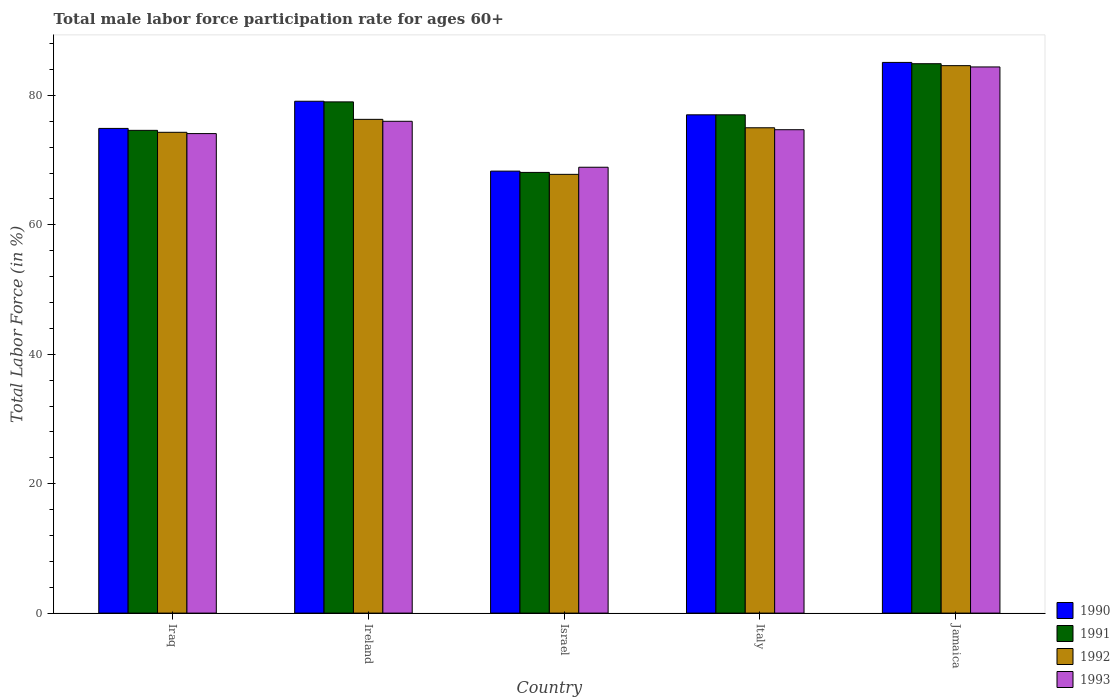How many different coloured bars are there?
Ensure brevity in your answer.  4. How many bars are there on the 1st tick from the right?
Your answer should be very brief. 4. What is the label of the 5th group of bars from the left?
Provide a short and direct response. Jamaica. In how many cases, is the number of bars for a given country not equal to the number of legend labels?
Give a very brief answer. 0. What is the male labor force participation rate in 1990 in Ireland?
Your response must be concise. 79.1. Across all countries, what is the maximum male labor force participation rate in 1992?
Your answer should be compact. 84.6. Across all countries, what is the minimum male labor force participation rate in 1990?
Your answer should be very brief. 68.3. In which country was the male labor force participation rate in 1990 maximum?
Offer a terse response. Jamaica. In which country was the male labor force participation rate in 1990 minimum?
Your answer should be compact. Israel. What is the total male labor force participation rate in 1991 in the graph?
Keep it short and to the point. 383.6. What is the difference between the male labor force participation rate in 1992 in Israel and that in Jamaica?
Provide a short and direct response. -16.8. What is the difference between the male labor force participation rate in 1990 in Israel and the male labor force participation rate in 1991 in Jamaica?
Offer a very short reply. -16.6. What is the average male labor force participation rate in 1991 per country?
Give a very brief answer. 76.72. What is the difference between the male labor force participation rate of/in 1992 and male labor force participation rate of/in 1990 in Jamaica?
Your answer should be compact. -0.5. What is the ratio of the male labor force participation rate in 1992 in Italy to that in Jamaica?
Make the answer very short. 0.89. Is the difference between the male labor force participation rate in 1992 in Israel and Jamaica greater than the difference between the male labor force participation rate in 1990 in Israel and Jamaica?
Provide a short and direct response. No. What is the difference between the highest and the second highest male labor force participation rate in 1990?
Make the answer very short. -8.1. What is the difference between the highest and the lowest male labor force participation rate in 1990?
Your answer should be very brief. 16.8. Is the sum of the male labor force participation rate in 1991 in Israel and Italy greater than the maximum male labor force participation rate in 1990 across all countries?
Keep it short and to the point. Yes. What does the 1st bar from the right in Jamaica represents?
Make the answer very short. 1993. Is it the case that in every country, the sum of the male labor force participation rate in 1993 and male labor force participation rate in 1992 is greater than the male labor force participation rate in 1990?
Your answer should be very brief. Yes. Are all the bars in the graph horizontal?
Offer a terse response. No. Does the graph contain grids?
Your response must be concise. No. Where does the legend appear in the graph?
Offer a terse response. Bottom right. What is the title of the graph?
Make the answer very short. Total male labor force participation rate for ages 60+. What is the label or title of the X-axis?
Your answer should be very brief. Country. What is the label or title of the Y-axis?
Give a very brief answer. Total Labor Force (in %). What is the Total Labor Force (in %) of 1990 in Iraq?
Provide a succinct answer. 74.9. What is the Total Labor Force (in %) of 1991 in Iraq?
Your answer should be very brief. 74.6. What is the Total Labor Force (in %) of 1992 in Iraq?
Keep it short and to the point. 74.3. What is the Total Labor Force (in %) of 1993 in Iraq?
Your answer should be compact. 74.1. What is the Total Labor Force (in %) of 1990 in Ireland?
Ensure brevity in your answer.  79.1. What is the Total Labor Force (in %) of 1991 in Ireland?
Provide a short and direct response. 79. What is the Total Labor Force (in %) in 1992 in Ireland?
Keep it short and to the point. 76.3. What is the Total Labor Force (in %) of 1993 in Ireland?
Provide a succinct answer. 76. What is the Total Labor Force (in %) in 1990 in Israel?
Keep it short and to the point. 68.3. What is the Total Labor Force (in %) in 1991 in Israel?
Ensure brevity in your answer.  68.1. What is the Total Labor Force (in %) of 1992 in Israel?
Ensure brevity in your answer.  67.8. What is the Total Labor Force (in %) of 1993 in Israel?
Keep it short and to the point. 68.9. What is the Total Labor Force (in %) in 1993 in Italy?
Offer a very short reply. 74.7. What is the Total Labor Force (in %) of 1990 in Jamaica?
Offer a very short reply. 85.1. What is the Total Labor Force (in %) of 1991 in Jamaica?
Give a very brief answer. 84.9. What is the Total Labor Force (in %) in 1992 in Jamaica?
Ensure brevity in your answer.  84.6. What is the Total Labor Force (in %) in 1993 in Jamaica?
Your answer should be compact. 84.4. Across all countries, what is the maximum Total Labor Force (in %) in 1990?
Your answer should be compact. 85.1. Across all countries, what is the maximum Total Labor Force (in %) of 1991?
Your answer should be very brief. 84.9. Across all countries, what is the maximum Total Labor Force (in %) of 1992?
Offer a very short reply. 84.6. Across all countries, what is the maximum Total Labor Force (in %) of 1993?
Ensure brevity in your answer.  84.4. Across all countries, what is the minimum Total Labor Force (in %) in 1990?
Ensure brevity in your answer.  68.3. Across all countries, what is the minimum Total Labor Force (in %) of 1991?
Your answer should be very brief. 68.1. Across all countries, what is the minimum Total Labor Force (in %) in 1992?
Provide a succinct answer. 67.8. Across all countries, what is the minimum Total Labor Force (in %) of 1993?
Offer a very short reply. 68.9. What is the total Total Labor Force (in %) of 1990 in the graph?
Make the answer very short. 384.4. What is the total Total Labor Force (in %) in 1991 in the graph?
Give a very brief answer. 383.6. What is the total Total Labor Force (in %) in 1992 in the graph?
Keep it short and to the point. 378. What is the total Total Labor Force (in %) in 1993 in the graph?
Give a very brief answer. 378.1. What is the difference between the Total Labor Force (in %) in 1990 in Iraq and that in Israel?
Your answer should be very brief. 6.6. What is the difference between the Total Labor Force (in %) of 1993 in Iraq and that in Israel?
Make the answer very short. 5.2. What is the difference between the Total Labor Force (in %) of 1993 in Iraq and that in Italy?
Offer a very short reply. -0.6. What is the difference between the Total Labor Force (in %) in 1990 in Iraq and that in Jamaica?
Offer a terse response. -10.2. What is the difference between the Total Labor Force (in %) of 1992 in Iraq and that in Jamaica?
Your answer should be very brief. -10.3. What is the difference between the Total Labor Force (in %) of 1993 in Iraq and that in Jamaica?
Provide a succinct answer. -10.3. What is the difference between the Total Labor Force (in %) of 1990 in Ireland and that in Israel?
Ensure brevity in your answer.  10.8. What is the difference between the Total Labor Force (in %) in 1991 in Ireland and that in Israel?
Provide a succinct answer. 10.9. What is the difference between the Total Labor Force (in %) in 1993 in Ireland and that in Israel?
Ensure brevity in your answer.  7.1. What is the difference between the Total Labor Force (in %) of 1991 in Ireland and that in Italy?
Offer a very short reply. 2. What is the difference between the Total Labor Force (in %) in 1990 in Ireland and that in Jamaica?
Offer a very short reply. -6. What is the difference between the Total Labor Force (in %) of 1991 in Ireland and that in Jamaica?
Your answer should be very brief. -5.9. What is the difference between the Total Labor Force (in %) in 1992 in Ireland and that in Jamaica?
Your response must be concise. -8.3. What is the difference between the Total Labor Force (in %) in 1993 in Ireland and that in Jamaica?
Offer a terse response. -8.4. What is the difference between the Total Labor Force (in %) of 1990 in Israel and that in Italy?
Keep it short and to the point. -8.7. What is the difference between the Total Labor Force (in %) in 1993 in Israel and that in Italy?
Make the answer very short. -5.8. What is the difference between the Total Labor Force (in %) of 1990 in Israel and that in Jamaica?
Your answer should be very brief. -16.8. What is the difference between the Total Labor Force (in %) in 1991 in Israel and that in Jamaica?
Give a very brief answer. -16.8. What is the difference between the Total Labor Force (in %) of 1992 in Israel and that in Jamaica?
Provide a succinct answer. -16.8. What is the difference between the Total Labor Force (in %) in 1993 in Israel and that in Jamaica?
Your response must be concise. -15.5. What is the difference between the Total Labor Force (in %) in 1991 in Italy and that in Jamaica?
Keep it short and to the point. -7.9. What is the difference between the Total Labor Force (in %) of 1990 in Iraq and the Total Labor Force (in %) of 1993 in Ireland?
Ensure brevity in your answer.  -1.1. What is the difference between the Total Labor Force (in %) in 1991 in Iraq and the Total Labor Force (in %) in 1993 in Ireland?
Keep it short and to the point. -1.4. What is the difference between the Total Labor Force (in %) of 1990 in Iraq and the Total Labor Force (in %) of 1993 in Israel?
Make the answer very short. 6. What is the difference between the Total Labor Force (in %) of 1991 in Iraq and the Total Labor Force (in %) of 1992 in Israel?
Provide a short and direct response. 6.8. What is the difference between the Total Labor Force (in %) in 1990 in Iraq and the Total Labor Force (in %) in 1993 in Italy?
Give a very brief answer. 0.2. What is the difference between the Total Labor Force (in %) of 1992 in Iraq and the Total Labor Force (in %) of 1993 in Italy?
Offer a terse response. -0.4. What is the difference between the Total Labor Force (in %) in 1990 in Iraq and the Total Labor Force (in %) in 1992 in Jamaica?
Provide a short and direct response. -9.7. What is the difference between the Total Labor Force (in %) in 1991 in Iraq and the Total Labor Force (in %) in 1992 in Jamaica?
Give a very brief answer. -10. What is the difference between the Total Labor Force (in %) in 1990 in Ireland and the Total Labor Force (in %) in 1991 in Israel?
Make the answer very short. 11. What is the difference between the Total Labor Force (in %) of 1990 in Ireland and the Total Labor Force (in %) of 1993 in Israel?
Offer a terse response. 10.2. What is the difference between the Total Labor Force (in %) of 1991 in Ireland and the Total Labor Force (in %) of 1992 in Israel?
Offer a terse response. 11.2. What is the difference between the Total Labor Force (in %) in 1990 in Ireland and the Total Labor Force (in %) in 1991 in Italy?
Provide a succinct answer. 2.1. What is the difference between the Total Labor Force (in %) in 1990 in Ireland and the Total Labor Force (in %) in 1992 in Italy?
Offer a very short reply. 4.1. What is the difference between the Total Labor Force (in %) in 1992 in Ireland and the Total Labor Force (in %) in 1993 in Italy?
Keep it short and to the point. 1.6. What is the difference between the Total Labor Force (in %) in 1990 in Ireland and the Total Labor Force (in %) in 1992 in Jamaica?
Your answer should be compact. -5.5. What is the difference between the Total Labor Force (in %) in 1990 in Ireland and the Total Labor Force (in %) in 1993 in Jamaica?
Offer a very short reply. -5.3. What is the difference between the Total Labor Force (in %) of 1991 in Ireland and the Total Labor Force (in %) of 1993 in Jamaica?
Provide a short and direct response. -5.4. What is the difference between the Total Labor Force (in %) in 1990 in Israel and the Total Labor Force (in %) in 1991 in Italy?
Your answer should be very brief. -8.7. What is the difference between the Total Labor Force (in %) of 1990 in Israel and the Total Labor Force (in %) of 1993 in Italy?
Provide a succinct answer. -6.4. What is the difference between the Total Labor Force (in %) of 1991 in Israel and the Total Labor Force (in %) of 1992 in Italy?
Keep it short and to the point. -6.9. What is the difference between the Total Labor Force (in %) of 1991 in Israel and the Total Labor Force (in %) of 1993 in Italy?
Provide a short and direct response. -6.6. What is the difference between the Total Labor Force (in %) of 1992 in Israel and the Total Labor Force (in %) of 1993 in Italy?
Keep it short and to the point. -6.9. What is the difference between the Total Labor Force (in %) in 1990 in Israel and the Total Labor Force (in %) in 1991 in Jamaica?
Keep it short and to the point. -16.6. What is the difference between the Total Labor Force (in %) in 1990 in Israel and the Total Labor Force (in %) in 1992 in Jamaica?
Offer a very short reply. -16.3. What is the difference between the Total Labor Force (in %) in 1990 in Israel and the Total Labor Force (in %) in 1993 in Jamaica?
Provide a short and direct response. -16.1. What is the difference between the Total Labor Force (in %) of 1991 in Israel and the Total Labor Force (in %) of 1992 in Jamaica?
Your response must be concise. -16.5. What is the difference between the Total Labor Force (in %) in 1991 in Israel and the Total Labor Force (in %) in 1993 in Jamaica?
Give a very brief answer. -16.3. What is the difference between the Total Labor Force (in %) of 1992 in Israel and the Total Labor Force (in %) of 1993 in Jamaica?
Your answer should be very brief. -16.6. What is the difference between the Total Labor Force (in %) in 1990 in Italy and the Total Labor Force (in %) in 1993 in Jamaica?
Your answer should be very brief. -7.4. What is the difference between the Total Labor Force (in %) of 1991 in Italy and the Total Labor Force (in %) of 1992 in Jamaica?
Your answer should be compact. -7.6. What is the difference between the Total Labor Force (in %) in 1992 in Italy and the Total Labor Force (in %) in 1993 in Jamaica?
Ensure brevity in your answer.  -9.4. What is the average Total Labor Force (in %) of 1990 per country?
Ensure brevity in your answer.  76.88. What is the average Total Labor Force (in %) in 1991 per country?
Offer a terse response. 76.72. What is the average Total Labor Force (in %) of 1992 per country?
Give a very brief answer. 75.6. What is the average Total Labor Force (in %) of 1993 per country?
Offer a terse response. 75.62. What is the difference between the Total Labor Force (in %) of 1990 and Total Labor Force (in %) of 1991 in Iraq?
Ensure brevity in your answer.  0.3. What is the difference between the Total Labor Force (in %) in 1990 and Total Labor Force (in %) in 1992 in Iraq?
Your answer should be compact. 0.6. What is the difference between the Total Labor Force (in %) of 1990 and Total Labor Force (in %) of 1993 in Iraq?
Offer a terse response. 0.8. What is the difference between the Total Labor Force (in %) of 1991 and Total Labor Force (in %) of 1993 in Iraq?
Ensure brevity in your answer.  0.5. What is the difference between the Total Labor Force (in %) in 1990 and Total Labor Force (in %) in 1991 in Ireland?
Your answer should be compact. 0.1. What is the difference between the Total Labor Force (in %) of 1990 and Total Labor Force (in %) of 1993 in Ireland?
Your response must be concise. 3.1. What is the difference between the Total Labor Force (in %) of 1991 and Total Labor Force (in %) of 1993 in Ireland?
Offer a very short reply. 3. What is the difference between the Total Labor Force (in %) of 1990 and Total Labor Force (in %) of 1991 in Israel?
Give a very brief answer. 0.2. What is the difference between the Total Labor Force (in %) in 1990 and Total Labor Force (in %) in 1992 in Israel?
Keep it short and to the point. 0.5. What is the difference between the Total Labor Force (in %) of 1990 and Total Labor Force (in %) of 1993 in Israel?
Give a very brief answer. -0.6. What is the difference between the Total Labor Force (in %) in 1990 and Total Labor Force (in %) in 1991 in Italy?
Offer a very short reply. 0. What is the difference between the Total Labor Force (in %) of 1990 and Total Labor Force (in %) of 1992 in Italy?
Provide a succinct answer. 2. What is the difference between the Total Labor Force (in %) in 1991 and Total Labor Force (in %) in 1992 in Italy?
Offer a terse response. 2. What is the difference between the Total Labor Force (in %) in 1990 and Total Labor Force (in %) in 1991 in Jamaica?
Your answer should be compact. 0.2. What is the difference between the Total Labor Force (in %) of 1991 and Total Labor Force (in %) of 1992 in Jamaica?
Your answer should be very brief. 0.3. What is the difference between the Total Labor Force (in %) in 1991 and Total Labor Force (in %) in 1993 in Jamaica?
Make the answer very short. 0.5. What is the difference between the Total Labor Force (in %) in 1992 and Total Labor Force (in %) in 1993 in Jamaica?
Your response must be concise. 0.2. What is the ratio of the Total Labor Force (in %) of 1990 in Iraq to that in Ireland?
Ensure brevity in your answer.  0.95. What is the ratio of the Total Labor Force (in %) in 1991 in Iraq to that in Ireland?
Give a very brief answer. 0.94. What is the ratio of the Total Labor Force (in %) in 1992 in Iraq to that in Ireland?
Offer a terse response. 0.97. What is the ratio of the Total Labor Force (in %) in 1990 in Iraq to that in Israel?
Offer a very short reply. 1.1. What is the ratio of the Total Labor Force (in %) in 1991 in Iraq to that in Israel?
Ensure brevity in your answer.  1.1. What is the ratio of the Total Labor Force (in %) of 1992 in Iraq to that in Israel?
Keep it short and to the point. 1.1. What is the ratio of the Total Labor Force (in %) in 1993 in Iraq to that in Israel?
Ensure brevity in your answer.  1.08. What is the ratio of the Total Labor Force (in %) in 1990 in Iraq to that in Italy?
Give a very brief answer. 0.97. What is the ratio of the Total Labor Force (in %) of 1991 in Iraq to that in Italy?
Offer a very short reply. 0.97. What is the ratio of the Total Labor Force (in %) in 1992 in Iraq to that in Italy?
Your answer should be very brief. 0.99. What is the ratio of the Total Labor Force (in %) in 1990 in Iraq to that in Jamaica?
Give a very brief answer. 0.88. What is the ratio of the Total Labor Force (in %) in 1991 in Iraq to that in Jamaica?
Keep it short and to the point. 0.88. What is the ratio of the Total Labor Force (in %) of 1992 in Iraq to that in Jamaica?
Your answer should be compact. 0.88. What is the ratio of the Total Labor Force (in %) in 1993 in Iraq to that in Jamaica?
Provide a succinct answer. 0.88. What is the ratio of the Total Labor Force (in %) in 1990 in Ireland to that in Israel?
Your answer should be compact. 1.16. What is the ratio of the Total Labor Force (in %) of 1991 in Ireland to that in Israel?
Give a very brief answer. 1.16. What is the ratio of the Total Labor Force (in %) of 1992 in Ireland to that in Israel?
Your answer should be very brief. 1.13. What is the ratio of the Total Labor Force (in %) of 1993 in Ireland to that in Israel?
Offer a terse response. 1.1. What is the ratio of the Total Labor Force (in %) in 1990 in Ireland to that in Italy?
Offer a very short reply. 1.03. What is the ratio of the Total Labor Force (in %) in 1992 in Ireland to that in Italy?
Give a very brief answer. 1.02. What is the ratio of the Total Labor Force (in %) of 1993 in Ireland to that in Italy?
Provide a short and direct response. 1.02. What is the ratio of the Total Labor Force (in %) of 1990 in Ireland to that in Jamaica?
Make the answer very short. 0.93. What is the ratio of the Total Labor Force (in %) in 1991 in Ireland to that in Jamaica?
Provide a short and direct response. 0.93. What is the ratio of the Total Labor Force (in %) of 1992 in Ireland to that in Jamaica?
Make the answer very short. 0.9. What is the ratio of the Total Labor Force (in %) of 1993 in Ireland to that in Jamaica?
Give a very brief answer. 0.9. What is the ratio of the Total Labor Force (in %) of 1990 in Israel to that in Italy?
Your answer should be compact. 0.89. What is the ratio of the Total Labor Force (in %) in 1991 in Israel to that in Italy?
Give a very brief answer. 0.88. What is the ratio of the Total Labor Force (in %) in 1992 in Israel to that in Italy?
Provide a succinct answer. 0.9. What is the ratio of the Total Labor Force (in %) in 1993 in Israel to that in Italy?
Offer a very short reply. 0.92. What is the ratio of the Total Labor Force (in %) of 1990 in Israel to that in Jamaica?
Your answer should be very brief. 0.8. What is the ratio of the Total Labor Force (in %) in 1991 in Israel to that in Jamaica?
Your response must be concise. 0.8. What is the ratio of the Total Labor Force (in %) in 1992 in Israel to that in Jamaica?
Your answer should be compact. 0.8. What is the ratio of the Total Labor Force (in %) in 1993 in Israel to that in Jamaica?
Provide a short and direct response. 0.82. What is the ratio of the Total Labor Force (in %) of 1990 in Italy to that in Jamaica?
Provide a succinct answer. 0.9. What is the ratio of the Total Labor Force (in %) of 1991 in Italy to that in Jamaica?
Keep it short and to the point. 0.91. What is the ratio of the Total Labor Force (in %) of 1992 in Italy to that in Jamaica?
Your answer should be very brief. 0.89. What is the ratio of the Total Labor Force (in %) in 1993 in Italy to that in Jamaica?
Give a very brief answer. 0.89. What is the difference between the highest and the second highest Total Labor Force (in %) of 1990?
Provide a succinct answer. 6. What is the difference between the highest and the second highest Total Labor Force (in %) in 1991?
Offer a terse response. 5.9. What is the difference between the highest and the second highest Total Labor Force (in %) of 1992?
Offer a terse response. 8.3. What is the difference between the highest and the lowest Total Labor Force (in %) of 1992?
Give a very brief answer. 16.8. What is the difference between the highest and the lowest Total Labor Force (in %) of 1993?
Your answer should be very brief. 15.5. 